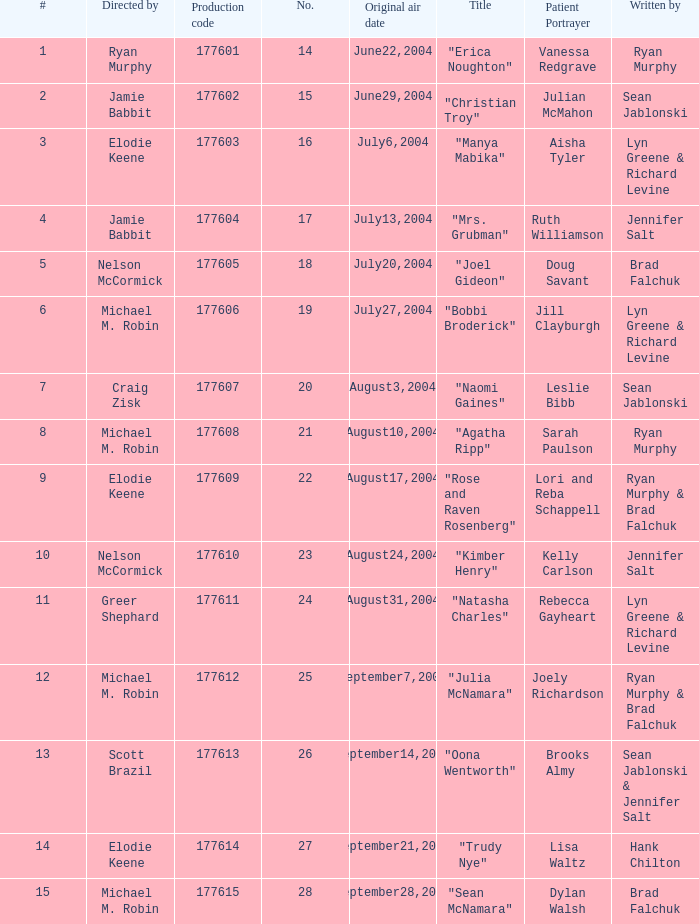Who directed the episode with production code 177605? Nelson McCormick. 